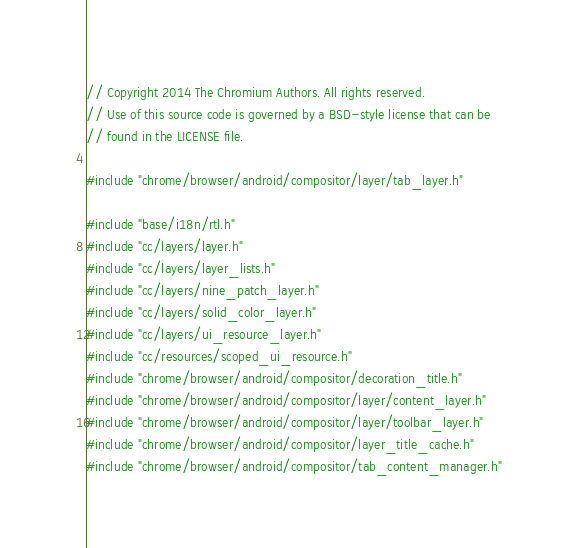Convert code to text. <code><loc_0><loc_0><loc_500><loc_500><_C++_>// Copyright 2014 The Chromium Authors. All rights reserved.
// Use of this source code is governed by a BSD-style license that can be
// found in the LICENSE file.

#include "chrome/browser/android/compositor/layer/tab_layer.h"

#include "base/i18n/rtl.h"
#include "cc/layers/layer.h"
#include "cc/layers/layer_lists.h"
#include "cc/layers/nine_patch_layer.h"
#include "cc/layers/solid_color_layer.h"
#include "cc/layers/ui_resource_layer.h"
#include "cc/resources/scoped_ui_resource.h"
#include "chrome/browser/android/compositor/decoration_title.h"
#include "chrome/browser/android/compositor/layer/content_layer.h"
#include "chrome/browser/android/compositor/layer/toolbar_layer.h"
#include "chrome/browser/android/compositor/layer_title_cache.h"
#include "chrome/browser/android/compositor/tab_content_manager.h"</code> 